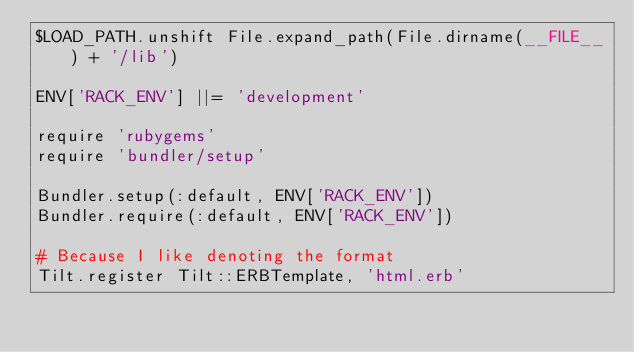<code> <loc_0><loc_0><loc_500><loc_500><_Ruby_>$LOAD_PATH.unshift File.expand_path(File.dirname(__FILE__) + '/lib')

ENV['RACK_ENV'] ||= 'development'

require 'rubygems'
require 'bundler/setup'

Bundler.setup(:default, ENV['RACK_ENV'])
Bundler.require(:default, ENV['RACK_ENV'])

# Because I like denoting the format
Tilt.register Tilt::ERBTemplate, 'html.erb'
</code> 